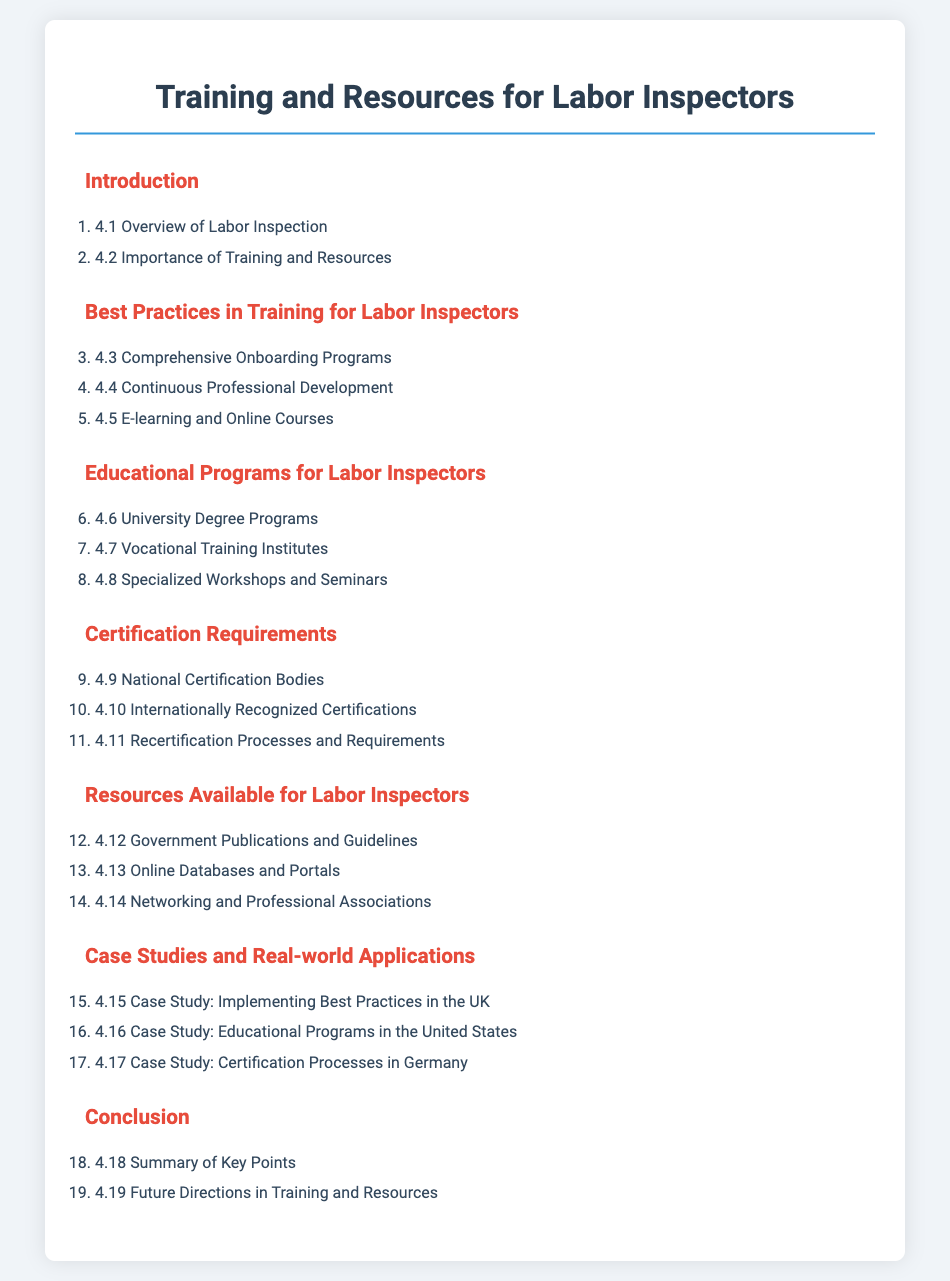what is the title of the document? The title is explicitly stated at the beginning of the document as "Training and Resources for Labor Inspectors."
Answer: Training and Resources for Labor Inspectors how many sections are in the document? The document contains a total of 7 sections listed in the table of contents.
Answer: 7 what is the focus of section 4.4? Section 4.4 is about continuous professional development specific to labor inspectors, emphasizing ongoing learning.
Answer: Continuous Professional Development what types of educational programs are mentioned? Educational programs listed include university degree programs, vocational training institutes, and specialized workshops and seminars.
Answer: University Degree Programs, Vocational Training Institutes, Specialized Workshops and Seminars which certification body is mentioned first in section 4.9? Section 4.9 refers to national certification bodies, which establish standards for labor inspectors' qualifications.
Answer: National Certification Bodies what examples of case studies are provided in the document? The document includes case studies such as implementing best practices in the UK and certification processes in Germany, highlighting practical applications.
Answer: Implementing Best Practices in the UK, Certification Processes in Germany what is the last section of the document? The last section of the document focuses on the conclusion, summarizing the key points discussed earlier.
Answer: Conclusion 